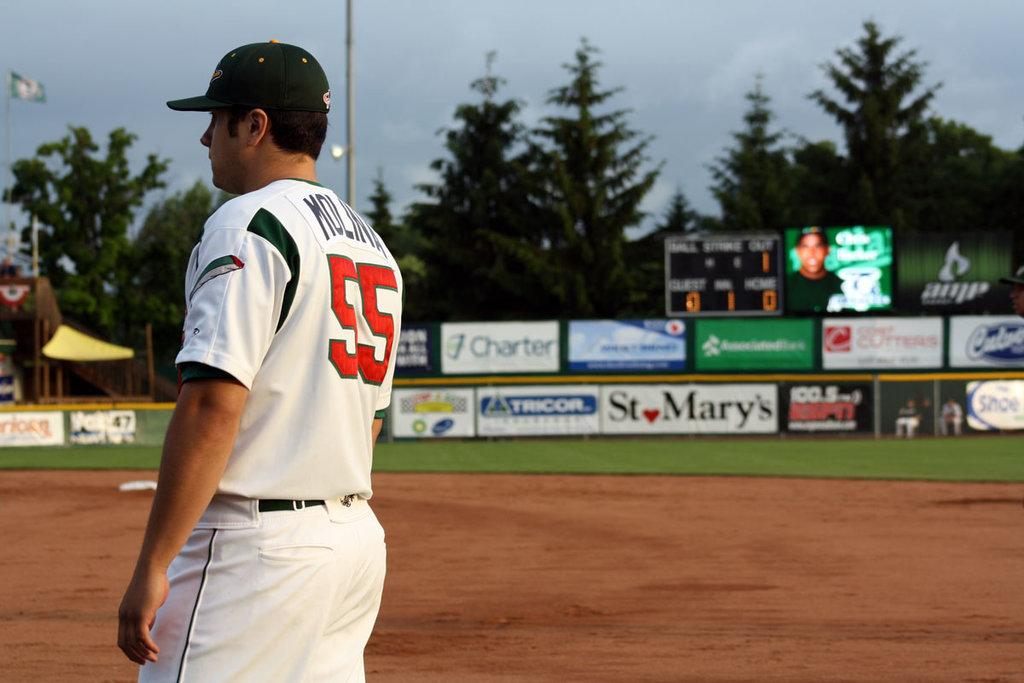<image>
Write a terse but informative summary of the picture. A ball player wears a uniform with number 55 on the back. 